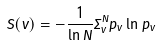<formula> <loc_0><loc_0><loc_500><loc_500>S ( v ) = - \frac { 1 } { \ln N } \Sigma _ { v } ^ { N } p _ { v } \ln p _ { v }</formula> 